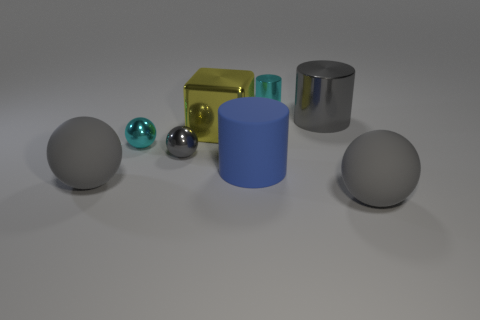How many gray balls must be subtracted to get 1 gray balls? 2 Subtract all brown cylinders. How many gray balls are left? 3 Add 2 big cyan matte spheres. How many objects exist? 10 Subtract all cylinders. How many objects are left? 5 Add 2 large gray things. How many large gray things exist? 5 Subtract 0 blue blocks. How many objects are left? 8 Subtract all tiny objects. Subtract all metallic cylinders. How many objects are left? 3 Add 5 blue matte objects. How many blue matte objects are left? 6 